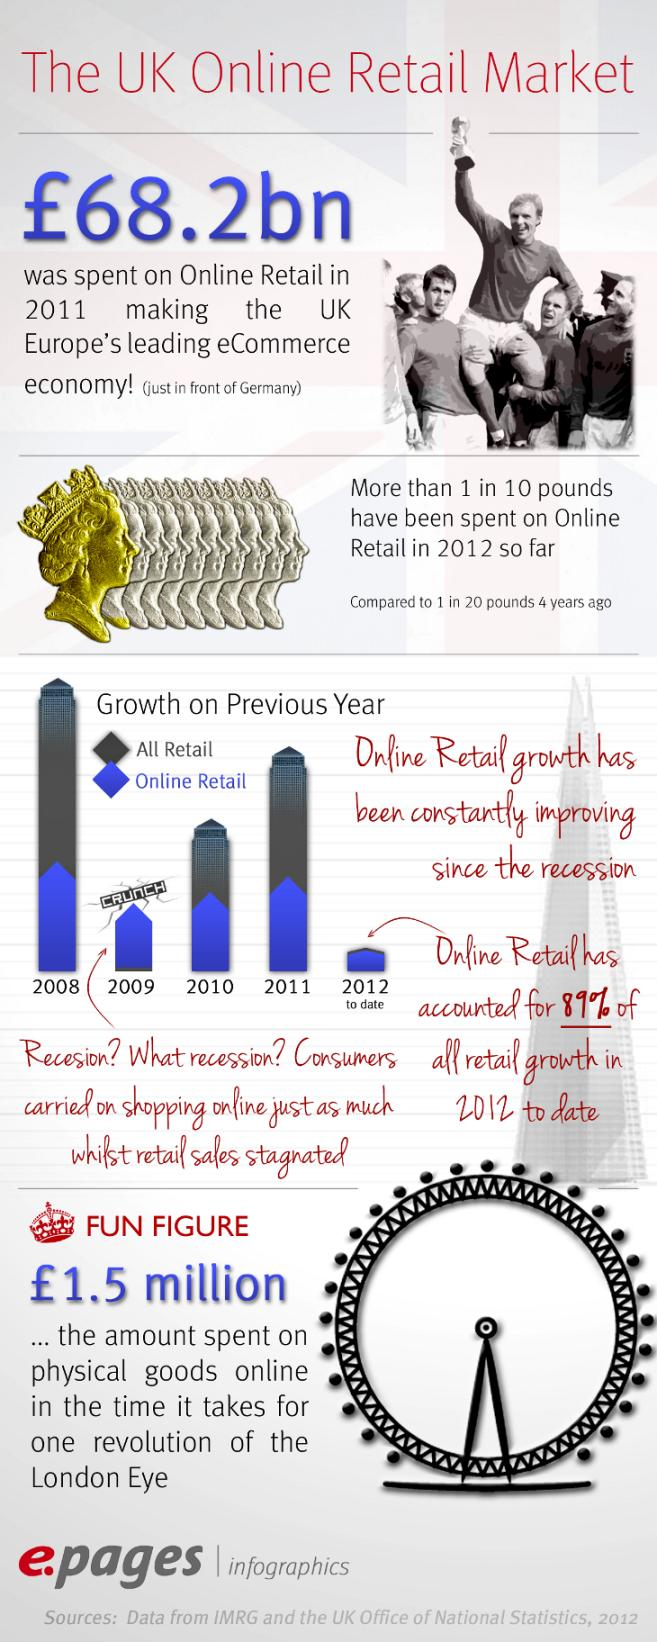Point out several critical features in this image. Germany led Europe's eCommerce economy in 2011, followed by the second-place country. During the period from 2008 to 2012, there was a 5% increase in expenditure on online retail. 